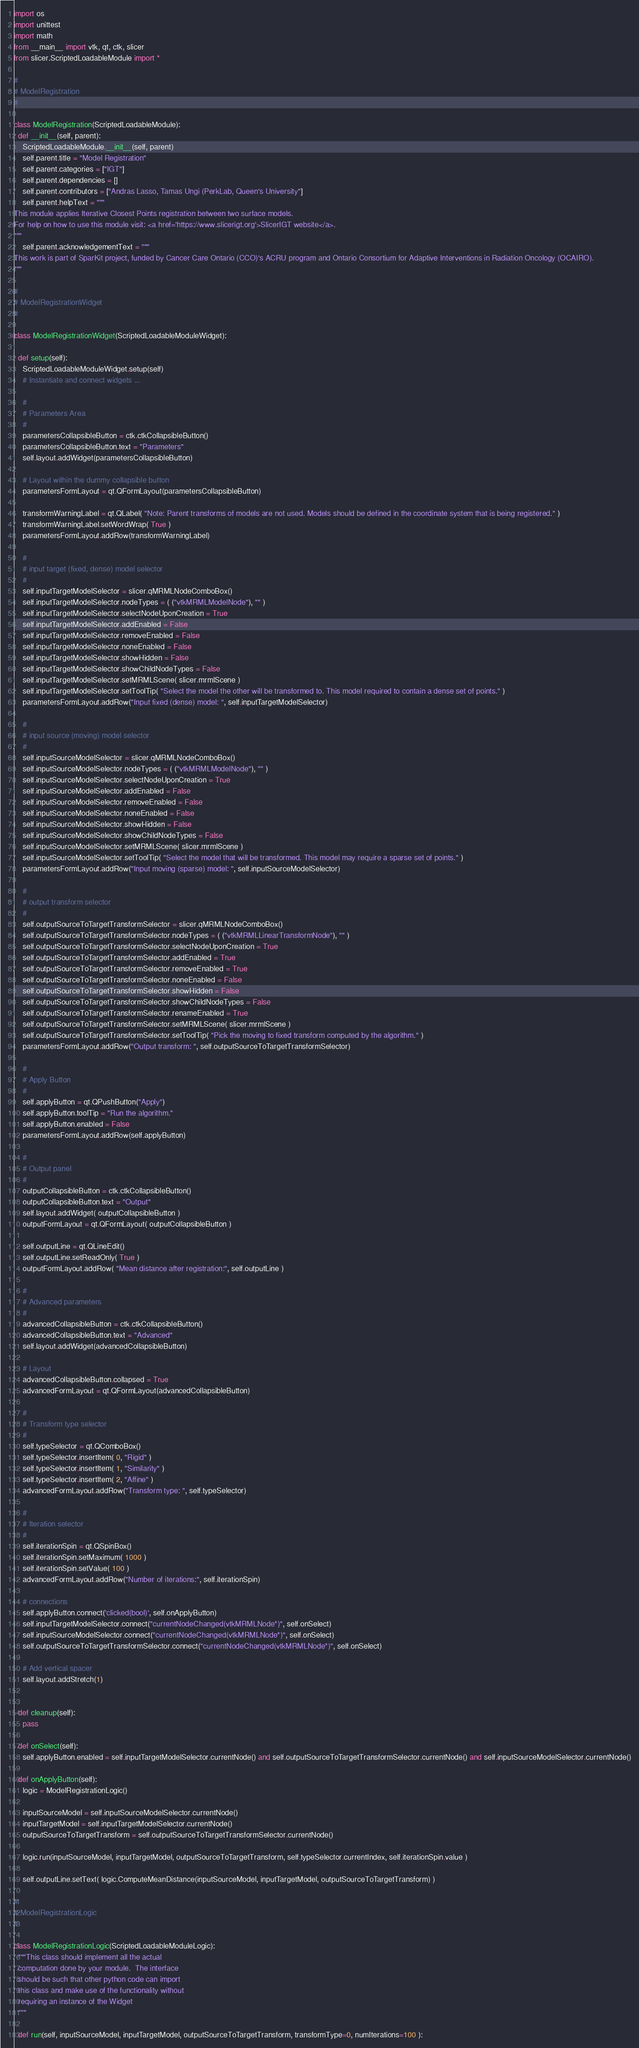Convert code to text. <code><loc_0><loc_0><loc_500><loc_500><_Python_>import os
import unittest
import math
from __main__ import vtk, qt, ctk, slicer
from slicer.ScriptedLoadableModule import *

#
# ModelRegistration
#

class ModelRegistration(ScriptedLoadableModule):
  def __init__(self, parent):
    ScriptedLoadableModule.__init__(self, parent)
    self.parent.title = "Model Registration"
    self.parent.categories = ["IGT"]
    self.parent.dependencies = []
    self.parent.contributors = ["Andras Lasso, Tamas Ungi (PerkLab, Queen's University"]
    self.parent.helpText = """
This module applies Iterative Closest Points registration between two surface models.
For help on how to use this module visit: <a href='https://www.slicerigt.org'>SlicerIGT website</a>.
"""
    self.parent.acknowledgementText = """
This work is part of SparKit project, funded by Cancer Care Ontario (CCO)'s ACRU program and Ontario Consortium for Adaptive Interventions in Radiation Oncology (OCAIRO).
"""

#
# ModelRegistrationWidget
#

class ModelRegistrationWidget(ScriptedLoadableModuleWidget):

  def setup(self):
    ScriptedLoadableModuleWidget.setup(self)
    # Instantiate and connect widgets ...

    #
    # Parameters Area
    #
    parametersCollapsibleButton = ctk.ctkCollapsibleButton()
    parametersCollapsibleButton.text = "Parameters"
    self.layout.addWidget(parametersCollapsibleButton)

    # Layout within the dummy collapsible button
    parametersFormLayout = qt.QFormLayout(parametersCollapsibleButton)

    transformWarningLabel = qt.QLabel( "Note: Parent transforms of models are not used. Models should be defined in the coordinate system that is being registered." )
    transformWarningLabel.setWordWrap( True )
    parametersFormLayout.addRow(transformWarningLabel)

    #
    # input target (fixed, dense) model selector
    #
    self.inputTargetModelSelector = slicer.qMRMLNodeComboBox()
    self.inputTargetModelSelector.nodeTypes = ( ("vtkMRMLModelNode"), "" )
    self.inputTargetModelSelector.selectNodeUponCreation = True
    self.inputTargetModelSelector.addEnabled = False
    self.inputTargetModelSelector.removeEnabled = False
    self.inputTargetModelSelector.noneEnabled = False
    self.inputTargetModelSelector.showHidden = False
    self.inputTargetModelSelector.showChildNodeTypes = False
    self.inputTargetModelSelector.setMRMLScene( slicer.mrmlScene )
    self.inputTargetModelSelector.setToolTip( "Select the model the other will be transformed to. This model required to contain a dense set of points." )
    parametersFormLayout.addRow("Input fixed (dense) model: ", self.inputTargetModelSelector)

    #
    # input source (moving) model selector
    #
    self.inputSourceModelSelector = slicer.qMRMLNodeComboBox()
    self.inputSourceModelSelector.nodeTypes = ( ("vtkMRMLModelNode"), "" )
    self.inputSourceModelSelector.selectNodeUponCreation = True
    self.inputSourceModelSelector.addEnabled = False
    self.inputSourceModelSelector.removeEnabled = False
    self.inputSourceModelSelector.noneEnabled = False
    self.inputSourceModelSelector.showHidden = False
    self.inputSourceModelSelector.showChildNodeTypes = False
    self.inputSourceModelSelector.setMRMLScene( slicer.mrmlScene )
    self.inputSourceModelSelector.setToolTip( "Select the model that will be transformed. This model may require a sparse set of points." )
    parametersFormLayout.addRow("Input moving (sparse) model: ", self.inputSourceModelSelector)

    #
    # output transform selector
    #
    self.outputSourceToTargetTransformSelector = slicer.qMRMLNodeComboBox()
    self.outputSourceToTargetTransformSelector.nodeTypes = ( ("vtkMRMLLinearTransformNode"), "" )
    self.outputSourceToTargetTransformSelector.selectNodeUponCreation = True
    self.outputSourceToTargetTransformSelector.addEnabled = True
    self.outputSourceToTargetTransformSelector.removeEnabled = True
    self.outputSourceToTargetTransformSelector.noneEnabled = False
    self.outputSourceToTargetTransformSelector.showHidden = False
    self.outputSourceToTargetTransformSelector.showChildNodeTypes = False
    self.outputSourceToTargetTransformSelector.renameEnabled = True
    self.outputSourceToTargetTransformSelector.setMRMLScene( slicer.mrmlScene )
    self.outputSourceToTargetTransformSelector.setToolTip( "Pick the moving to fixed transform computed by the algorithm." )
    parametersFormLayout.addRow("Output transform: ", self.outputSourceToTargetTransformSelector)

    #
    # Apply Button
    #
    self.applyButton = qt.QPushButton("Apply")
    self.applyButton.toolTip = "Run the algorithm."
    self.applyButton.enabled = False
    parametersFormLayout.addRow(self.applyButton)

    #
    # Output panel
    #
    outputCollapsibleButton = ctk.ctkCollapsibleButton()
    outputCollapsibleButton.text = "Output"
    self.layout.addWidget( outputCollapsibleButton )
    outputFormLayout = qt.QFormLayout( outputCollapsibleButton )

    self.outputLine = qt.QLineEdit()
    self.outputLine.setReadOnly( True )
    outputFormLayout.addRow( "Mean distance after registration:", self.outputLine )

    #
    # Advanced parameters
    #
    advancedCollapsibleButton = ctk.ctkCollapsibleButton()
    advancedCollapsibleButton.text = "Advanced"
    self.layout.addWidget(advancedCollapsibleButton)

    # Layout
    advancedCollapsibleButton.collapsed = True
    advancedFormLayout = qt.QFormLayout(advancedCollapsibleButton)

    #
    # Transform type selector
    #
    self.typeSelector = qt.QComboBox()
    self.typeSelector.insertItem( 0, "Rigid" )
    self.typeSelector.insertItem( 1, "Similarity" )
    self.typeSelector.insertItem( 2, "Affine" )
    advancedFormLayout.addRow("Transform type: ", self.typeSelector)

    #
    # Iteration selector
    #
    self.iterationSpin = qt.QSpinBox()
    self.iterationSpin.setMaximum( 1000 )
    self.iterationSpin.setValue( 100 )
    advancedFormLayout.addRow("Number of iterations:", self.iterationSpin)

    # connections
    self.applyButton.connect('clicked(bool)', self.onApplyButton)
    self.inputTargetModelSelector.connect("currentNodeChanged(vtkMRMLNode*)", self.onSelect)
    self.inputSourceModelSelector.connect("currentNodeChanged(vtkMRMLNode*)", self.onSelect)
    self.outputSourceToTargetTransformSelector.connect("currentNodeChanged(vtkMRMLNode*)", self.onSelect)

    # Add vertical spacer
    self.layout.addStretch(1)


  def cleanup(self):
    pass

  def onSelect(self):
    self.applyButton.enabled = self.inputTargetModelSelector.currentNode() and self.outputSourceToTargetTransformSelector.currentNode() and self.inputSourceModelSelector.currentNode()

  def onApplyButton(self):
    logic = ModelRegistrationLogic()

    inputSourceModel = self.inputSourceModelSelector.currentNode()
    inputTargetModel = self.inputTargetModelSelector.currentNode()
    outputSourceToTargetTransform = self.outputSourceToTargetTransformSelector.currentNode()

    logic.run(inputSourceModel, inputTargetModel, outputSourceToTargetTransform, self.typeSelector.currentIndex, self.iterationSpin.value )

    self.outputLine.setText( logic.ComputeMeanDistance(inputSourceModel, inputTargetModel, outputSourceToTargetTransform) )

#
# ModelRegistrationLogic
#

class ModelRegistrationLogic(ScriptedLoadableModuleLogic):
  """This class should implement all the actual
  computation done by your module.  The interface
  should be such that other python code can import
  this class and make use of the functionality without
  requiring an instance of the Widget
  """

  def run(self, inputSourceModel, inputTargetModel, outputSourceToTargetTransform, transformType=0, numIterations=100 ):
</code> 